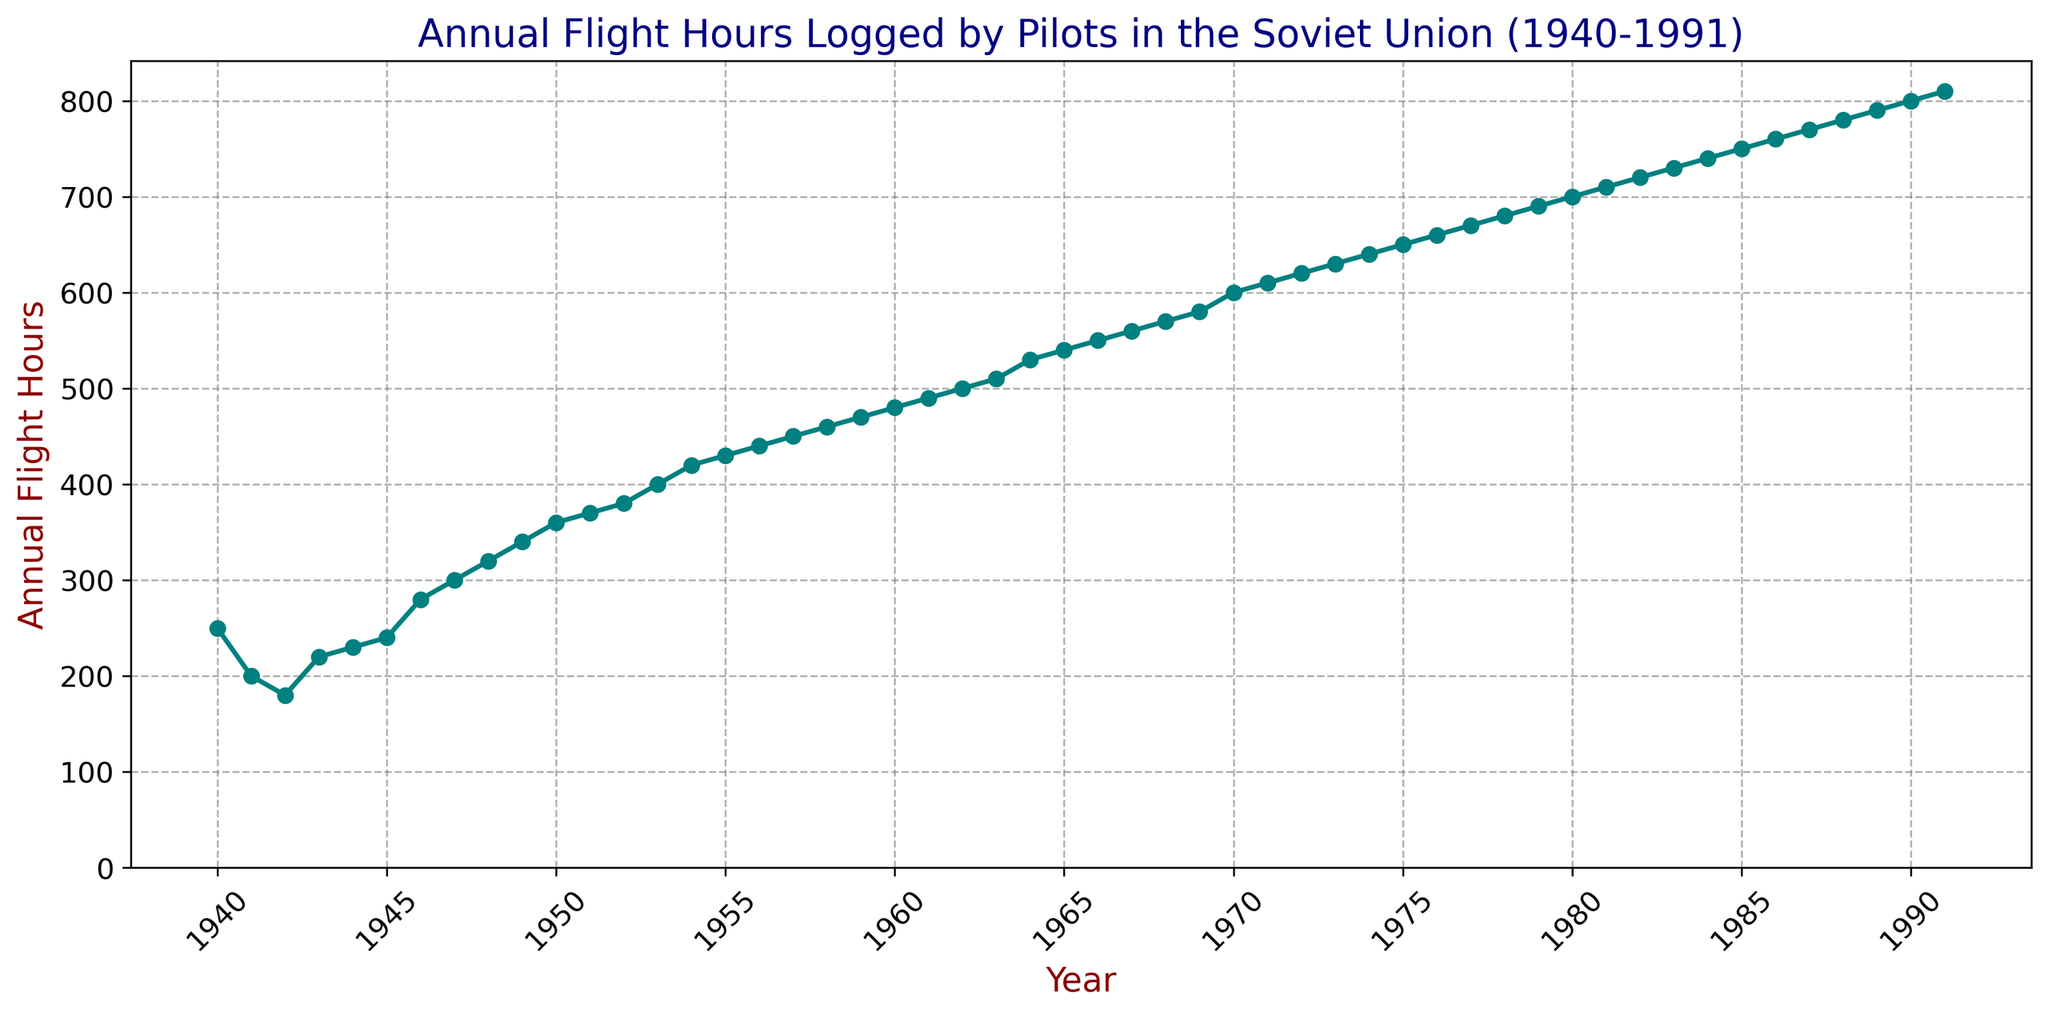What trend is observed in the annual flight hours from 1940 to 1991? To answer this, we look at the overall direction in which the data points move from 1940 to 1991. We see that the annual flight hours increase almost consistently over the years, with only a few slight dips in specific years. This indicates a general upward trend.
Answer: The annual flight hours show a steady upward trend What was the minimum value of annual flight hours, and in which year did it occur? To find the minimum value, we look for the lowest data point on the y-axis. From the figure, the minimum value is 180 hours, which occurred in 1942.
Answer: 180 hours in 1942 How does the annual flight hours in 1980 compare to that in 1940? We locate the data points for 1980 and 1940 and compare their values. In 1980, the flight hours were 700, while in 1940, they were 250.
Answer: 1980 was 450 hours more than 1940 Between which years did the steepest increase in annual flight hours occur? We identify segments of the plot with the sharpest rise. Notably, from 1969 to 1970, the increase was from 580 to 600, but the steepest jump might require a visual inspection of multiple intervals. The steepest appears to be between 1952 and 1953, where it increased from 380 to 400 flight hours.
Answer: 1952 to 1953 In which period did the annual flight hours surpass 500 for the first time? We find the data point where the y-value first exceeds 500. This occurs between 1962 and 1963, where flight hours go from 500 to 510.
Answer: Between 1962 and 1963 Calculate the average annual flight hours from 1940 to 1950. We sum the annual flight hours from 1940 (250) to 1950 (360) and divide by the number of years (11). Sum=250+200+180+220+230+240+280+300+320+340+360=2920; Average=2920/11=265.45
Answer: 265.45 hours What color is used to represent the line in the plot? To determine the color, we observe the line connecting the data points. The line is teal in color.
Answer: Teal Is there any year between 1940 and 1991 where the annual flight hours remained constant or show no change compared to the previous year? We identify data points where there is no change from one year to the next. However, examining the figure quickly shows that each year registers a different value, indicating no years with constant values.
Answer: No 